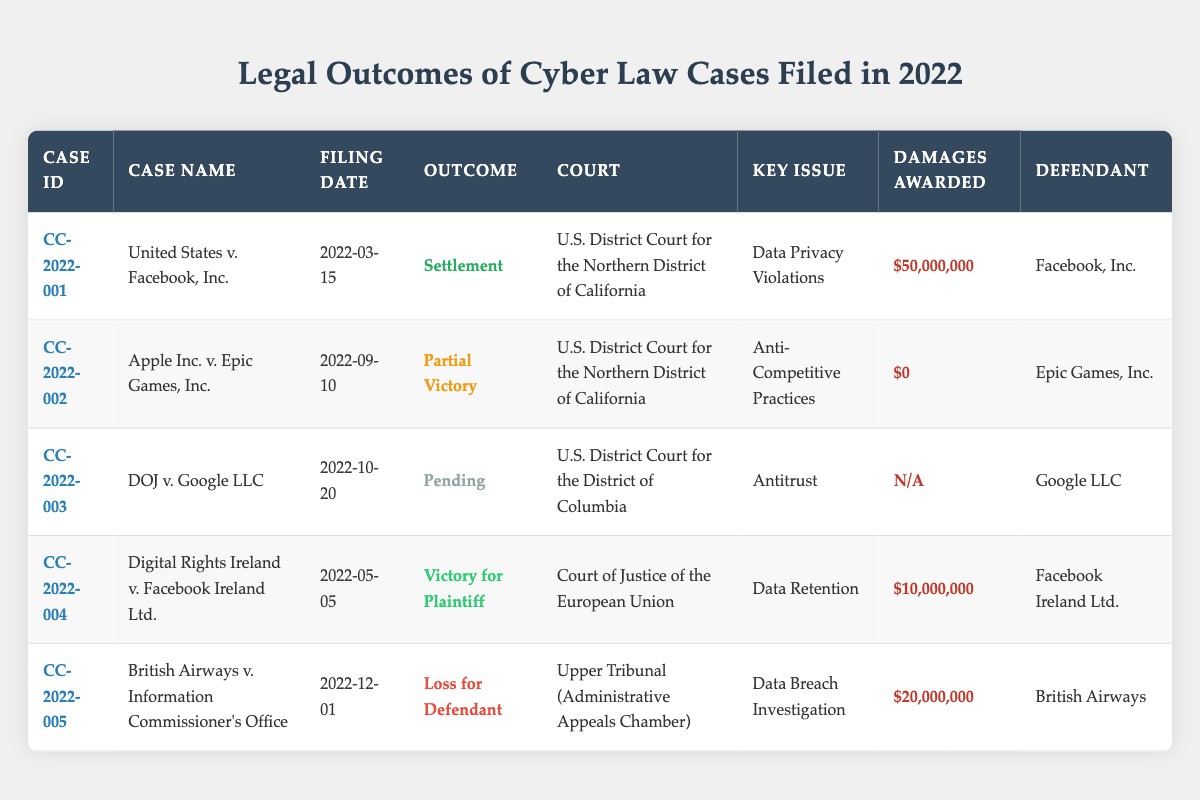What is the outcome of the case "United States v. Facebook, Inc."? The outcome is provided in the "Outcome" column corresponding to the case "United States v. Facebook, Inc." which is listed as "Settlement".
Answer: Settlement Which court handled the case "Apple Inc. v. Epic Games, Inc."? The court for the case "Apple Inc. v. Epic Games, Inc." can be found in the "Court" column next to this case, which states it was handled by the "U.S. District Court for the Northern District of California".
Answer: U.S. District Court for the Northern District of California What are the total damages awarded across all cases listed in the table? The total damages can be calculated by summing the "Damages Awarded" values from each case where damages are awarded: $50,000,000 (CC-2022-001) + $0 (CC-2022-002) + $10,000,000 (CC-2022-004) + $20,000,000 (CC-2022-005) = $80,000,000. The case "CC-2022-003" has no damages awarded since it is pending.
Answer: $80,000,000 Was there a case in 2022 where the defendant was found at fault, resulting in a monetary penalty? By checking the "Outcome" column, the cases with a specific monetary penalty for the defendant include "United States v. Facebook, Inc." and "British Airways v. Information Commissioner's Office", both of which resulted in damages awarded. Therefore, the statement is true.
Answer: Yes Which defendant has the largest damages awarded? The damages awarded are found in the "Damages Awarded" column. The largest value of damages awarded is $50,000,000 to "Facebook, Inc." from the case "United States v. Facebook, Inc.".
Answer: Facebook, Inc What was the key issue in the case "Digital Rights Ireland v. Facebook Ireland Ltd."? The key issue can be located in the "Key Issue" column for the case "Digital Rights Ireland v. Facebook Ireland Ltd.", where it states the key issue is "Data Retention".
Answer: Data Retention Is the case "DOJ v. Google LLC" resolved as of the filing date? The outcome for "DOJ v. Google LLC" is listed as "Pending," indicating that the case is not yet resolved as of the filing date of 2022-10-20.
Answer: No How many cases were decided in favor of the plaintiff in 2022? The table shows that the cases with outcomes in favor of the plaintiff are "United States v. Facebook, Inc." (Settlement) and "Digital Rights Ireland v. Facebook Ireland Ltd." (Victory for Plaintiff). Thus, there are two cases decided in favor of the plaintiff.
Answer: 2 What is the average damages awarded in cases that resulted in financial penalties? The cases with financial penalties are "United States v. Facebook, Inc." ($50,000,000), "Digital Rights Ireland v. Facebook Ireland Ltd." ($10,000,000), and "British Airways v. Information Commissioner's Office" ($20,000,000). Their total is $50,000,000 + $10,000,000 + $20,000,000 = $80,000,000. There are 3 cases, hence the average is $80,000,000 / 3 = approximately $26,666,667.
Answer: $26,666,667 